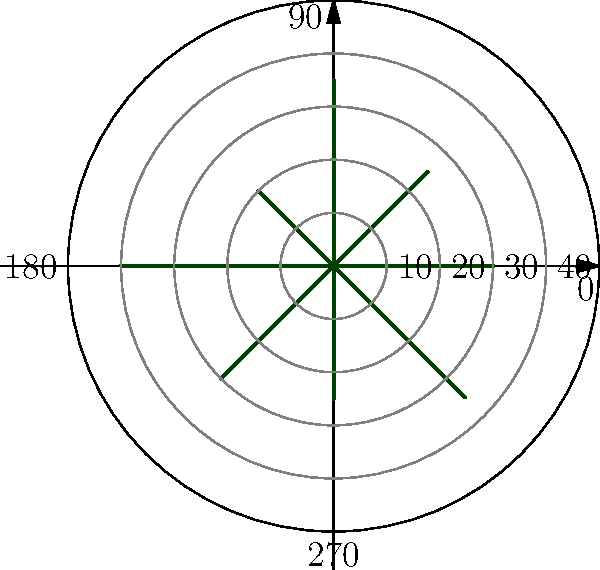As a supply coordinator for a military operation, you're tasked with analyzing supply routes on a polar grid. The graph shows 8 supply routes plotted on a polar coordinate system, where the angle represents the direction and the radius represents the distance in miles. What is the total distance covered by the two longest supply routes combined? To solve this problem, we need to follow these steps:

1. Identify all the supply routes and their distances:
   - $0°: 30$ miles
   - $45°: 25$ miles
   - $90°: 35$ miles
   - $135°: 20$ miles
   - $180°: 40$ miles
   - $225°: 30$ miles
   - $270°: 25$ miles
   - $315°: 35$ miles

2. Identify the two longest routes:
   - The longest route is at $180°$ with a distance of 40 miles.
   - The second longest routes are tied at $90°$ and $315°$, both with a distance of 35 miles.

3. Calculate the total distance:
   - Longest route: 40 miles
   - Second longest route: 35 miles
   - Total: $40 + 35 = 75$ miles

Therefore, the total distance covered by the two longest supply routes combined is 75 miles.
Answer: 75 miles 